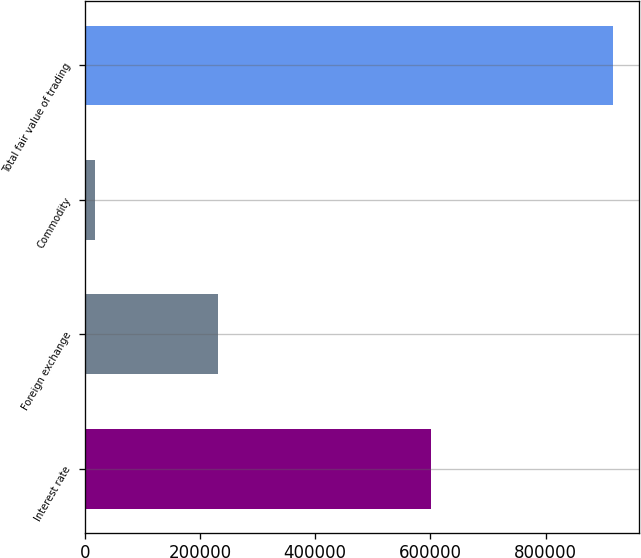Convert chart to OTSL. <chart><loc_0><loc_0><loc_500><loc_500><bar_chart><fcel>Interest rate<fcel>Foreign exchange<fcel>Commodity<fcel>Total fair value of trading<nl><fcel>601557<fcel>232137<fcel>18505<fcel>916784<nl></chart> 